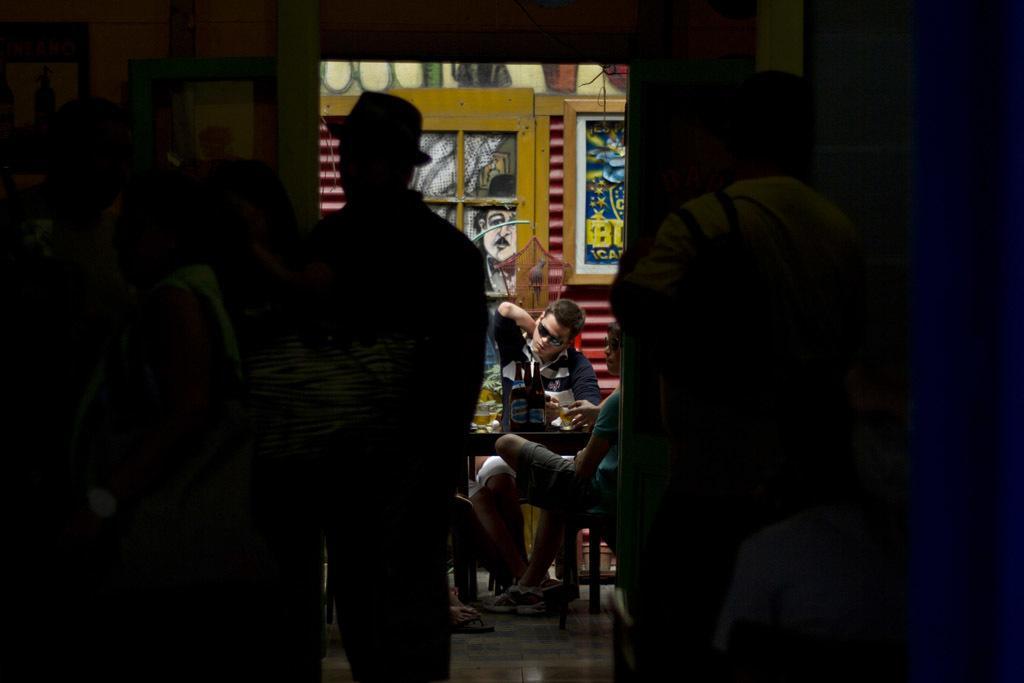Describe this image in one or two sentences. In the middle of the image we can see some persons sitting on the chairs and beverage and some food are placed on the table. Behind the persons in the middle we can see a wall and some paintings on it. on the left and right sides of the image we can see persons standing on the ground. 